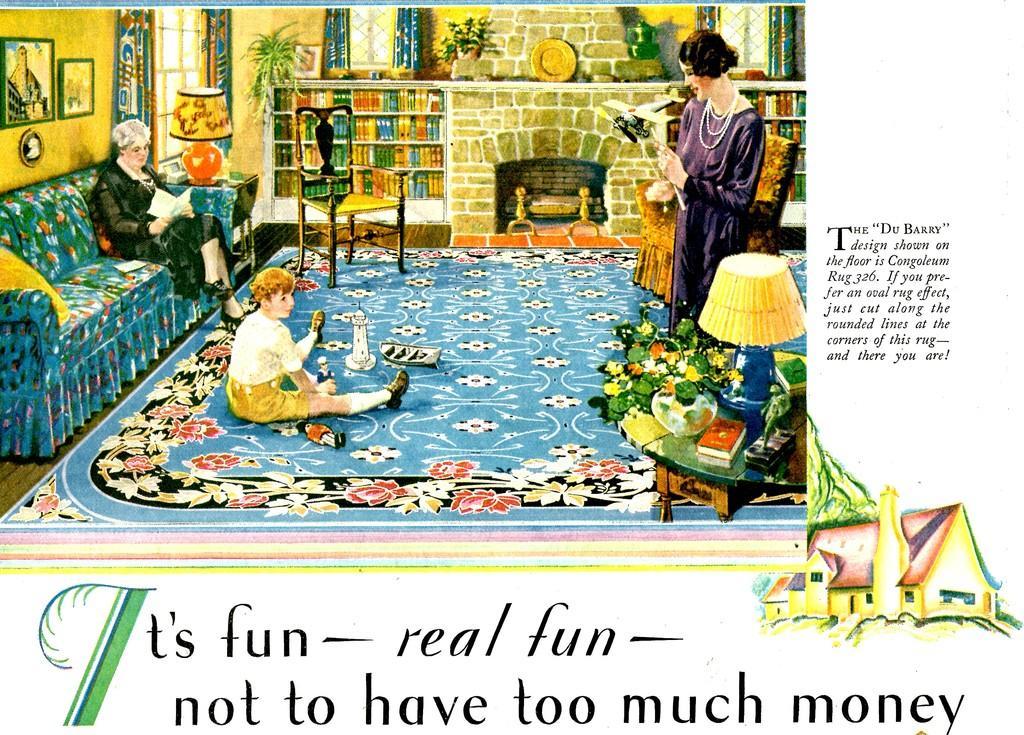Describe this image in one or two sentences. In the picture I can see an art in which we can see a person sitting on a sofa, a person sitting on the carpet and a person standing. Here we can see table lamp, chair, photo frames, curtains, a fireplace and books kept on the shelf. We can see some edited text at the bottom and right side of the image. Here we can see the house. 